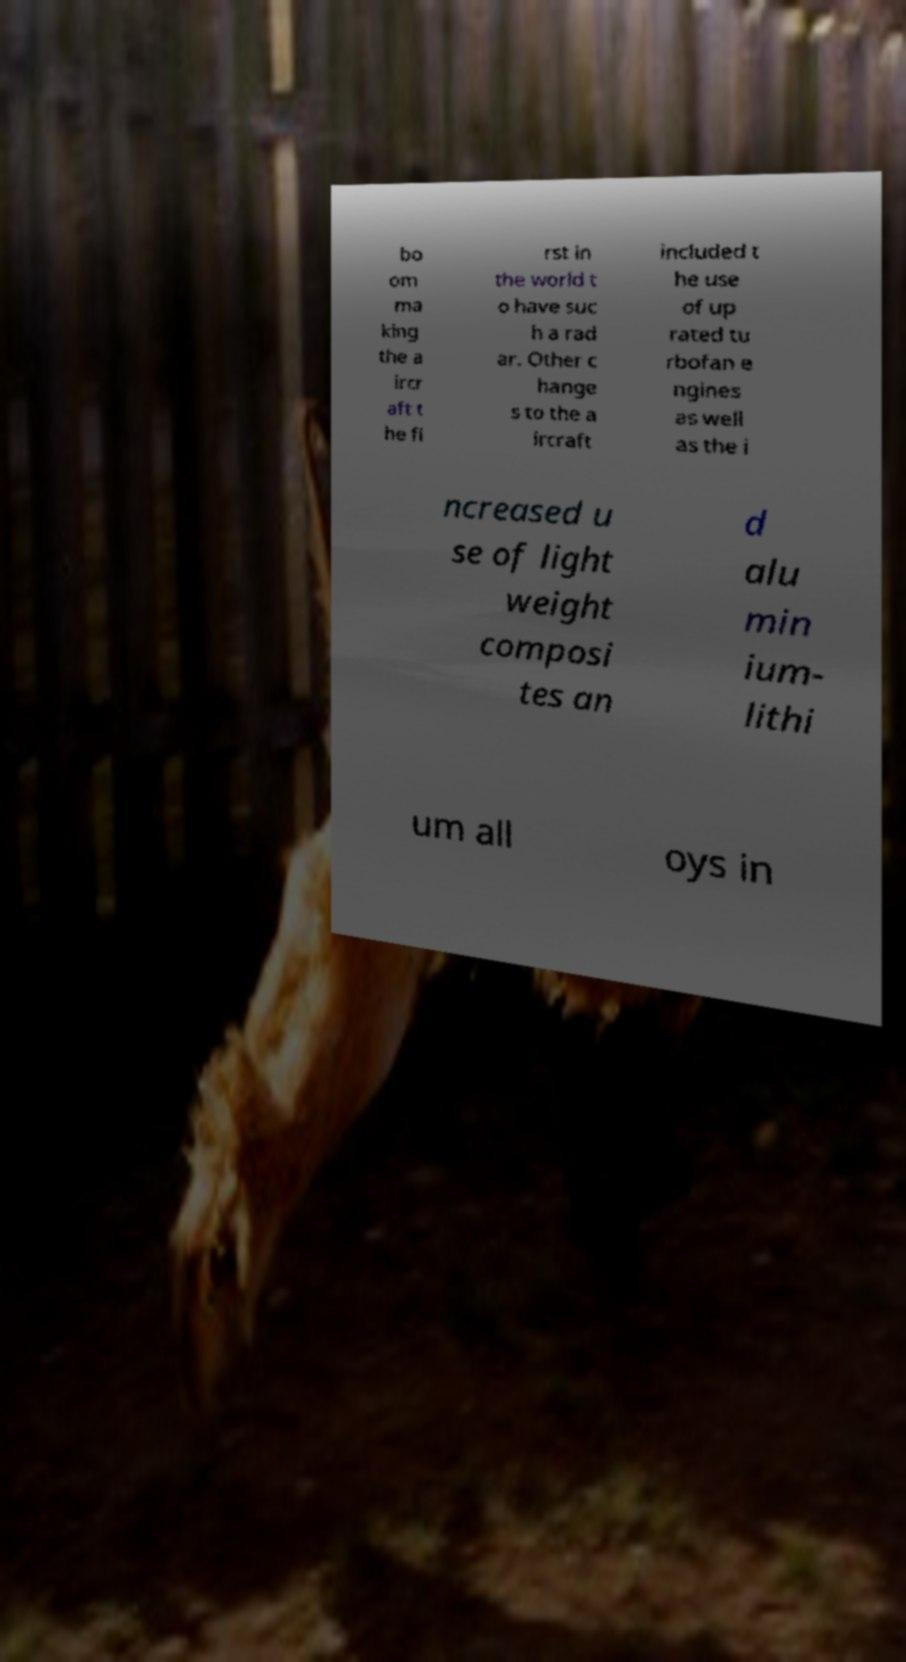I need the written content from this picture converted into text. Can you do that? bo om ma king the a ircr aft t he fi rst in the world t o have suc h a rad ar. Other c hange s to the a ircraft included t he use of up rated tu rbofan e ngines as well as the i ncreased u se of light weight composi tes an d alu min ium- lithi um all oys in 